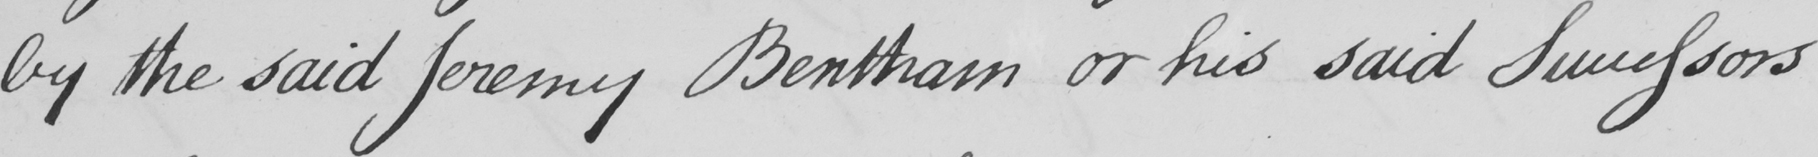Please provide the text content of this handwritten line. by the said Jeremy Bentham or his said Successors 